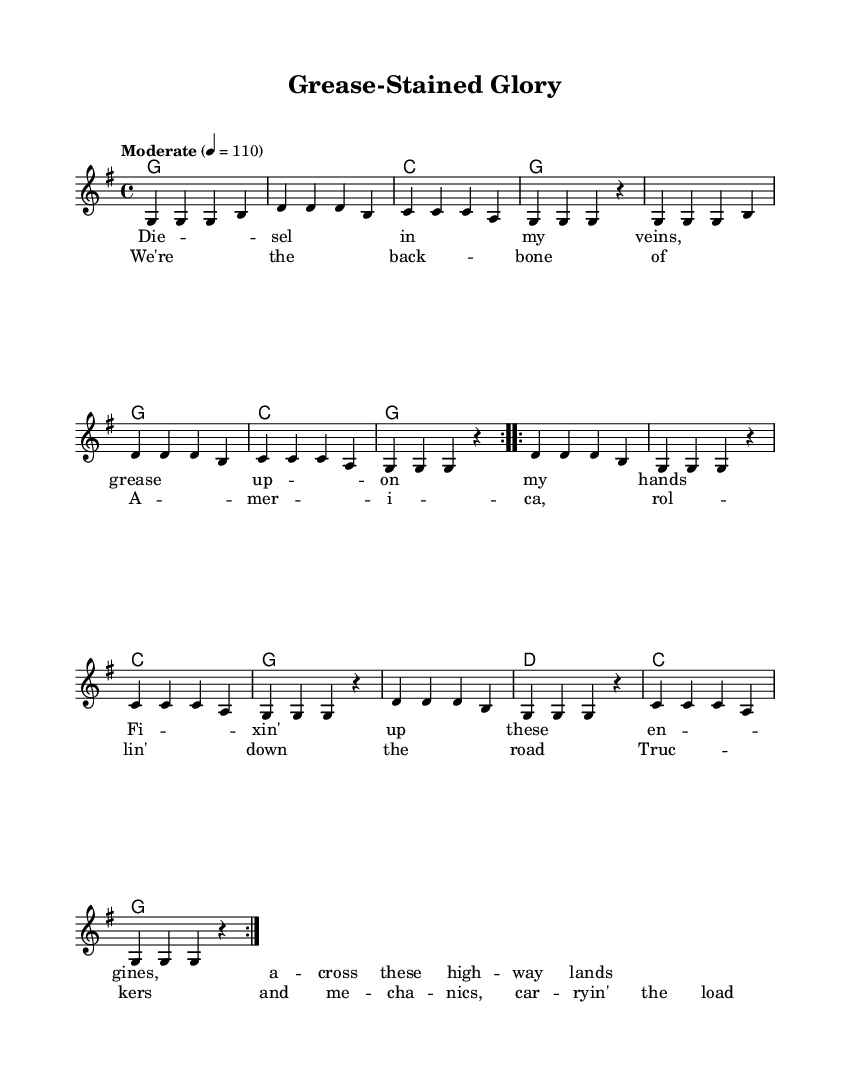What is the key signature of this music? The key signature is G major, which includes one sharp (F#). This can be identified by looking at the key signature section at the beginning of the music staff.
Answer: G major What is the time signature of this music? The time signature is 4/4, indicated at the beginning of the sheet music. This means there are four beats in each measure, and the quarter note receives one beat.
Answer: 4/4 What is the tempo marking for this song? The tempo marking indicates a moderate speed of 110 beats per minute. This is provided specifically in the tempo instruction at the beginning of the score.
Answer: 110 How many times is the main melody repeated? The main melody is repeated two times, which is indicated by the "repeat volta 2" marking in the music. This shows the section will be played twice.
Answer: 2 What genre does this song fall under? The song falls under the country genre, inferred from the lyrics that celebrate truck drivers and mechanics, which are typical themes in country music.
Answer: Country What is the final chord of the song? The final chord of the song is G major, as indicated by the last chord symbol in the harmony section of the score.
Answer: G major How many verses are present in this song? The song has two verses, as the lyrics are labeled as "verseWords" in the score, which corresponds to the melody that is followed by the chorus.
Answer: 2 